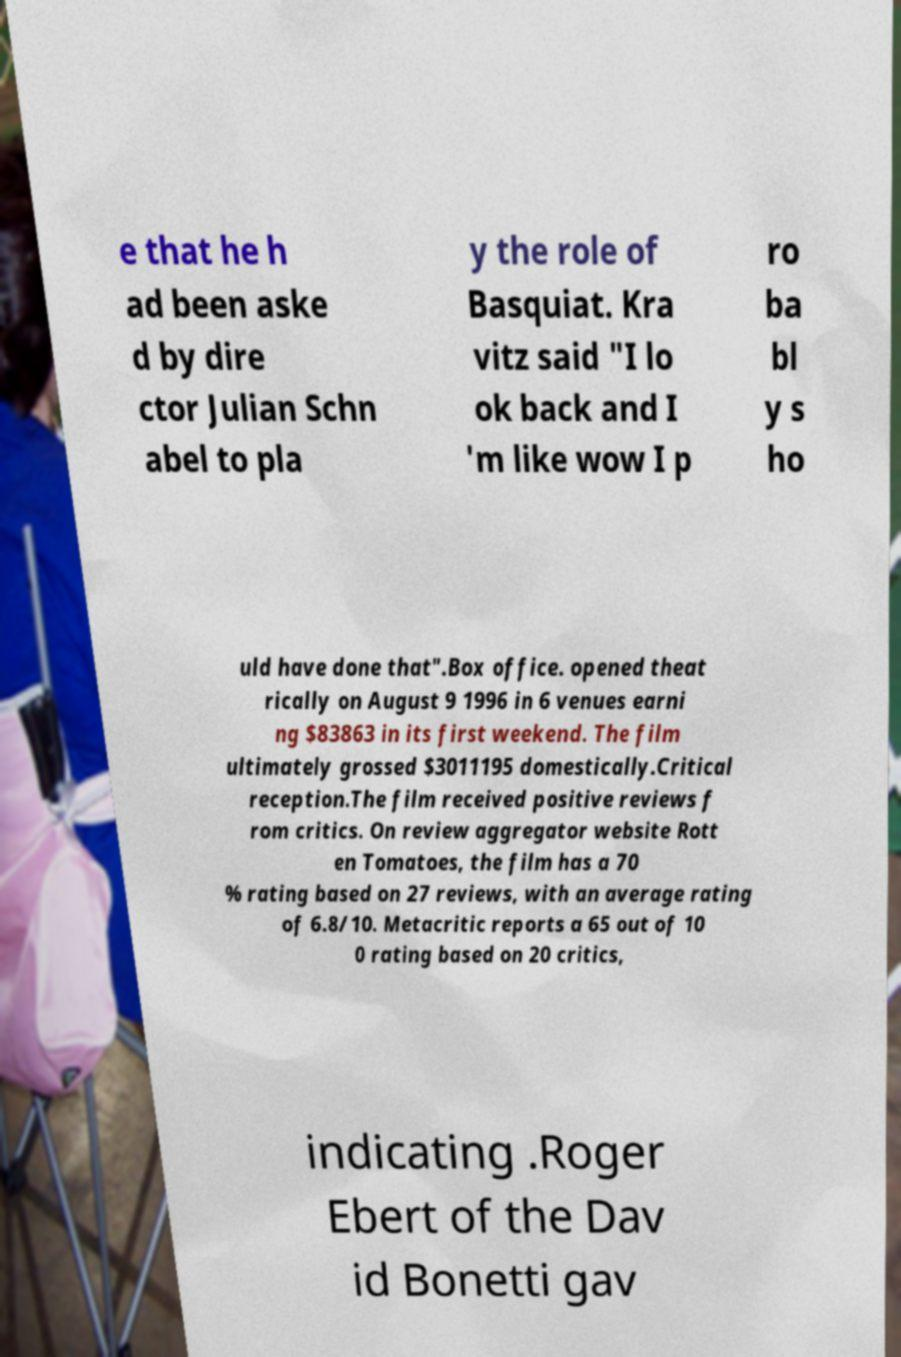Please identify and transcribe the text found in this image. e that he h ad been aske d by dire ctor Julian Schn abel to pla y the role of Basquiat. Kra vitz said "I lo ok back and I 'm like wow I p ro ba bl y s ho uld have done that".Box office. opened theat rically on August 9 1996 in 6 venues earni ng $83863 in its first weekend. The film ultimately grossed $3011195 domestically.Critical reception.The film received positive reviews f rom critics. On review aggregator website Rott en Tomatoes, the film has a 70 % rating based on 27 reviews, with an average rating of 6.8/10. Metacritic reports a 65 out of 10 0 rating based on 20 critics, indicating .Roger Ebert of the Dav id Bonetti gav 